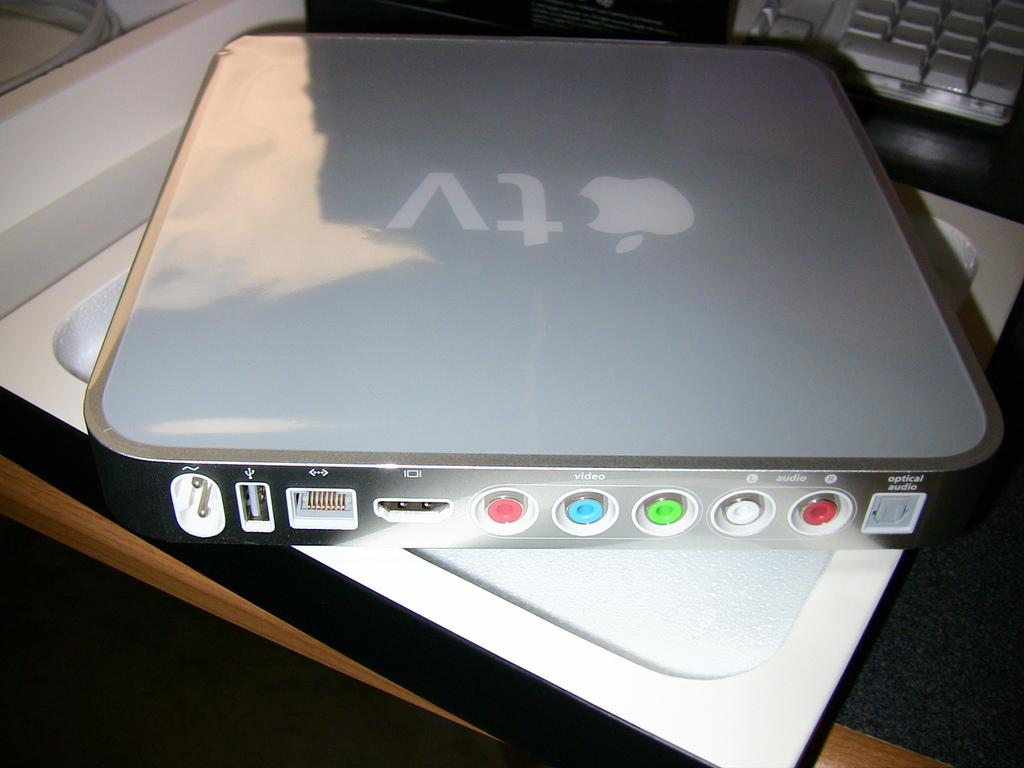<image>
Present a compact description of the photo's key features. A tablet with Apple Tv logo sitting on a table. 